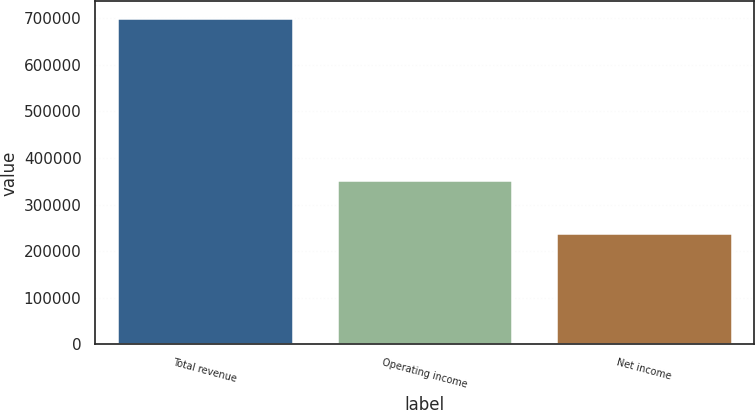Convert chart. <chart><loc_0><loc_0><loc_500><loc_500><bar_chart><fcel>Total revenue<fcel>Operating income<fcel>Net income<nl><fcel>701070<fcel>352109<fcel>238976<nl></chart> 